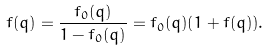Convert formula to latex. <formula><loc_0><loc_0><loc_500><loc_500>f ( { q } ) = \frac { f _ { 0 } ( { q } ) } { 1 - f _ { 0 } ( { q } ) } = f _ { 0 } ( { q } ) ( 1 + f ( { q } ) ) .</formula> 